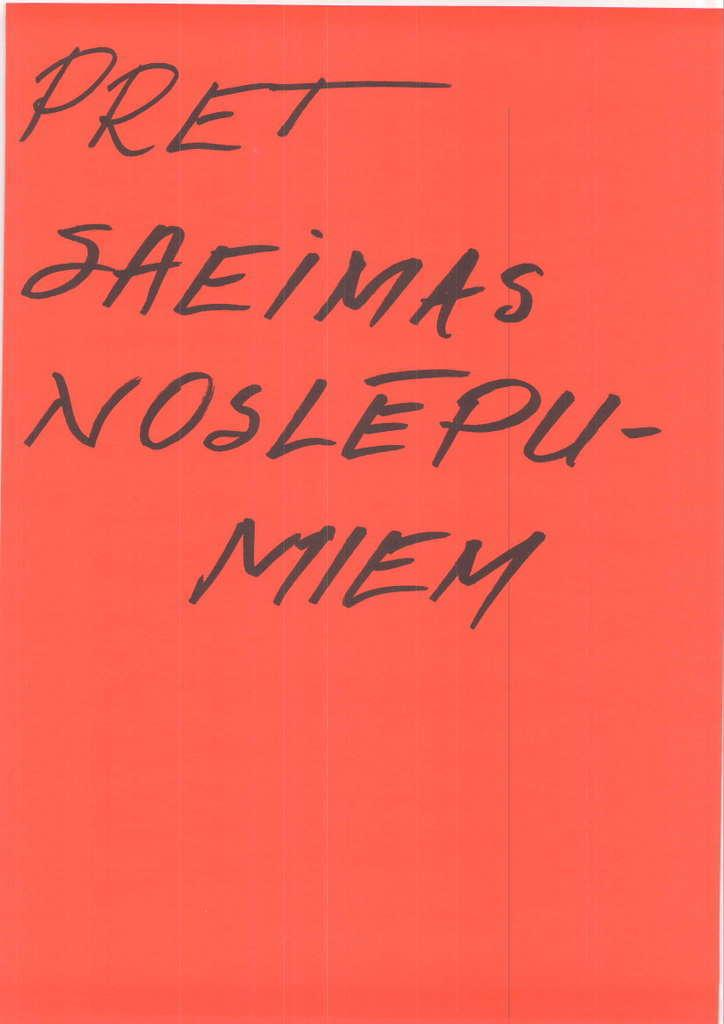Provide a one-sentence caption for the provided image. A red background displaying "PRET SAMEIMAS NOSLEPU - MEIM". 